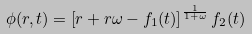Convert formula to latex. <formula><loc_0><loc_0><loc_500><loc_500>\phi ( r , t ) = \left [ r + r \omega - f _ { 1 } ( t ) \right ] ^ { \frac { 1 } { 1 + \omega } } f _ { 2 } ( t )</formula> 